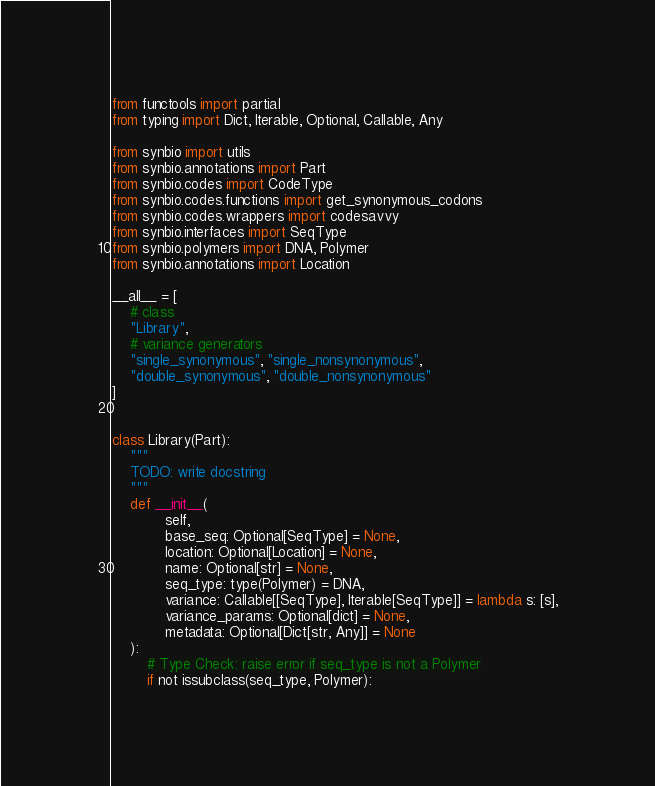<code> <loc_0><loc_0><loc_500><loc_500><_Python_>from functools import partial
from typing import Dict, Iterable, Optional, Callable, Any

from synbio import utils
from synbio.annotations import Part
from synbio.codes import CodeType
from synbio.codes.functions import get_synonymous_codons
from synbio.codes.wrappers import codesavvy
from synbio.interfaces import SeqType
from synbio.polymers import DNA, Polymer
from synbio.annotations import Location

__all__ = [
    # class
    "Library",
    # variance generators
    "single_synonymous", "single_nonsynonymous",
    "double_synonymous", "double_nonsynonymous"
]


class Library(Part):
    """
    TODO: write docstring
    """
    def __init__(
            self,
            base_seq: Optional[SeqType] = None,
            location: Optional[Location] = None,
            name: Optional[str] = None,
            seq_type: type(Polymer) = DNA,
            variance: Callable[[SeqType], Iterable[SeqType]] = lambda s: [s],
            variance_params: Optional[dict] = None,
            metadata: Optional[Dict[str, Any]] = None
    ):
        # Type Check: raise error if seq_type is not a Polymer
        if not issubclass(seq_type, Polymer):</code> 